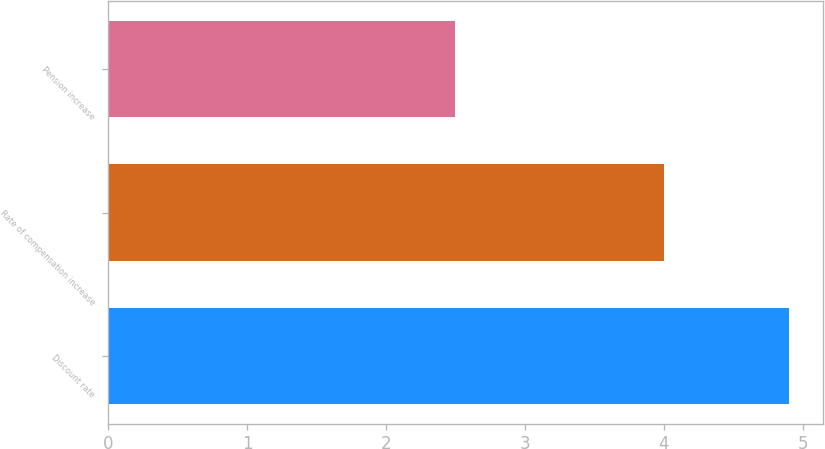Convert chart. <chart><loc_0><loc_0><loc_500><loc_500><bar_chart><fcel>Discount rate<fcel>Rate of compensation increase<fcel>Pension increase<nl><fcel>4.9<fcel>4<fcel>2.5<nl></chart> 